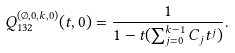<formula> <loc_0><loc_0><loc_500><loc_500>Q _ { 1 3 2 } ^ { ( \emptyset , 0 , k , 0 ) } ( t , 0 ) = \frac { 1 } { 1 - t ( \sum _ { j = 0 } ^ { k - 1 } C _ { j } t ^ { j } ) } .</formula> 